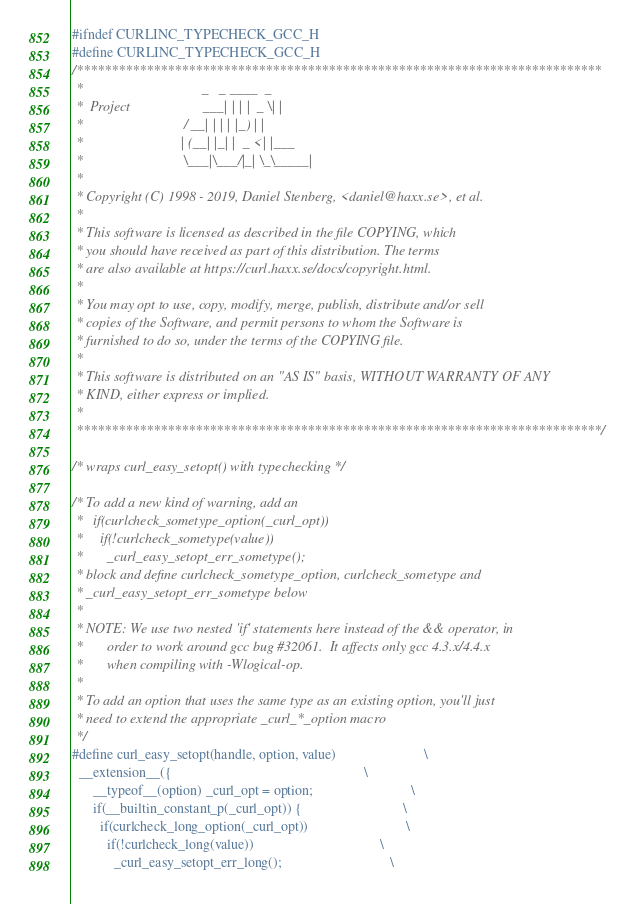Convert code to text. <code><loc_0><loc_0><loc_500><loc_500><_C_>#ifndef CURLINC_TYPECHECK_GCC_H
#define CURLINC_TYPECHECK_GCC_H
/***************************************************************************
 *                                  _   _ ____  _
 *  Project                     ___| | | |  _ \| |
 *                             / __| | | | |_) | |
 *                            | (__| |_| |  _ <| |___
 *                             \___|\___/|_| \_\_____|
 *
 * Copyright (C) 1998 - 2019, Daniel Stenberg, <daniel@haxx.se>, et al.
 *
 * This software is licensed as described in the file COPYING, which
 * you should have received as part of this distribution. The terms
 * are also available at https://curl.haxx.se/docs/copyright.html.
 *
 * You may opt to use, copy, modify, merge, publish, distribute and/or sell
 * copies of the Software, and permit persons to whom the Software is
 * furnished to do so, under the terms of the COPYING file.
 *
 * This software is distributed on an "AS IS" basis, WITHOUT WARRANTY OF ANY
 * KIND, either express or implied.
 *
 ***************************************************************************/

/* wraps curl_easy_setopt() with typechecking */

/* To add a new kind of warning, add an
 *   if(curlcheck_sometype_option(_curl_opt))
 *     if(!curlcheck_sometype(value))
 *       _curl_easy_setopt_err_sometype();
 * block and define curlcheck_sometype_option, curlcheck_sometype and
 * _curl_easy_setopt_err_sometype below
 *
 * NOTE: We use two nested 'if' statements here instead of the && operator, in
 *       order to work around gcc bug #32061.  It affects only gcc 4.3.x/4.4.x
 *       when compiling with -Wlogical-op.
 *
 * To add an option that uses the same type as an existing option, you'll just
 * need to extend the appropriate _curl_*_option macro
 */
#define curl_easy_setopt(handle, option, value)                         \
  __extension__({                                                       \
      __typeof__(option) _curl_opt = option;                            \
      if(__builtin_constant_p(_curl_opt)) {                             \
        if(curlcheck_long_option(_curl_opt))                            \
          if(!curlcheck_long(value))                                    \
            _curl_easy_setopt_err_long();                               \</code> 